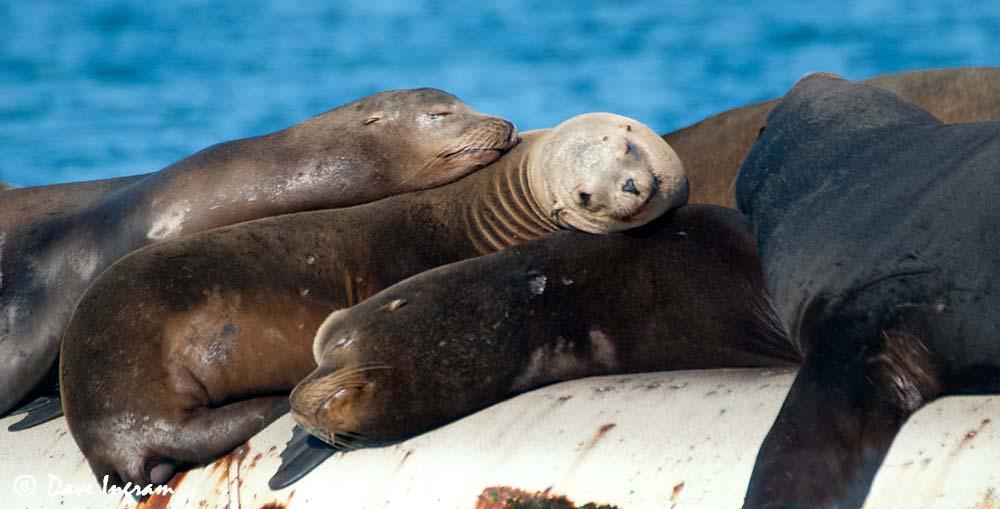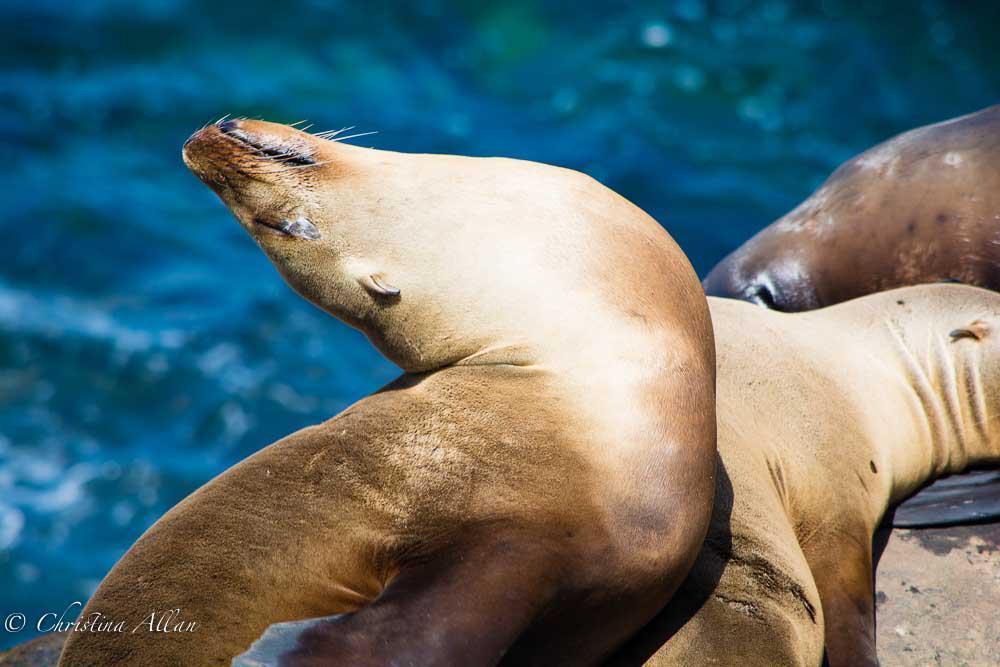The first image is the image on the left, the second image is the image on the right. For the images displayed, is the sentence "One image has no more than three seals laying on rocks." factually correct? Answer yes or no. Yes. The first image is the image on the left, the second image is the image on the right. Analyze the images presented: Is the assertion "In at least one image there are seals laying on a wooden dock" valid? Answer yes or no. No. 